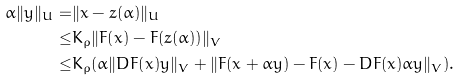<formula> <loc_0><loc_0><loc_500><loc_500>\alpha \| y \| _ { U } = & \| x - z ( \alpha ) \| _ { U } \\ \leq & K _ { \rho } \| F ( x ) - F ( z ( \alpha ) ) \| _ { V } \\ \leq & K _ { \rho } ( \alpha \| D F ( x ) y \| _ { V } + \| F ( x + \alpha y ) - F ( x ) - D F ( x ) \alpha y \| _ { V } ) .</formula> 